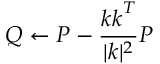<formula> <loc_0><loc_0><loc_500><loc_500>Q \gets P - \frac { \boldsymbol k \boldsymbol k ^ { T } } { | \boldsymbol k | ^ { 2 } } P</formula> 